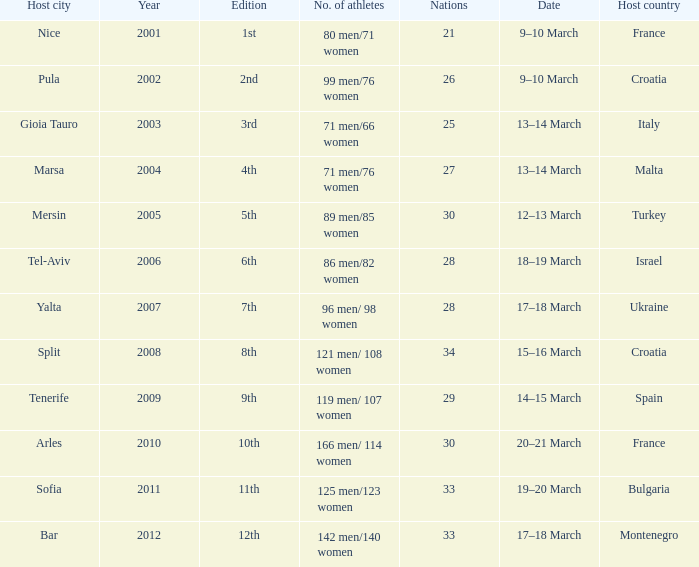In what year was Montenegro the host country? 2012.0. 